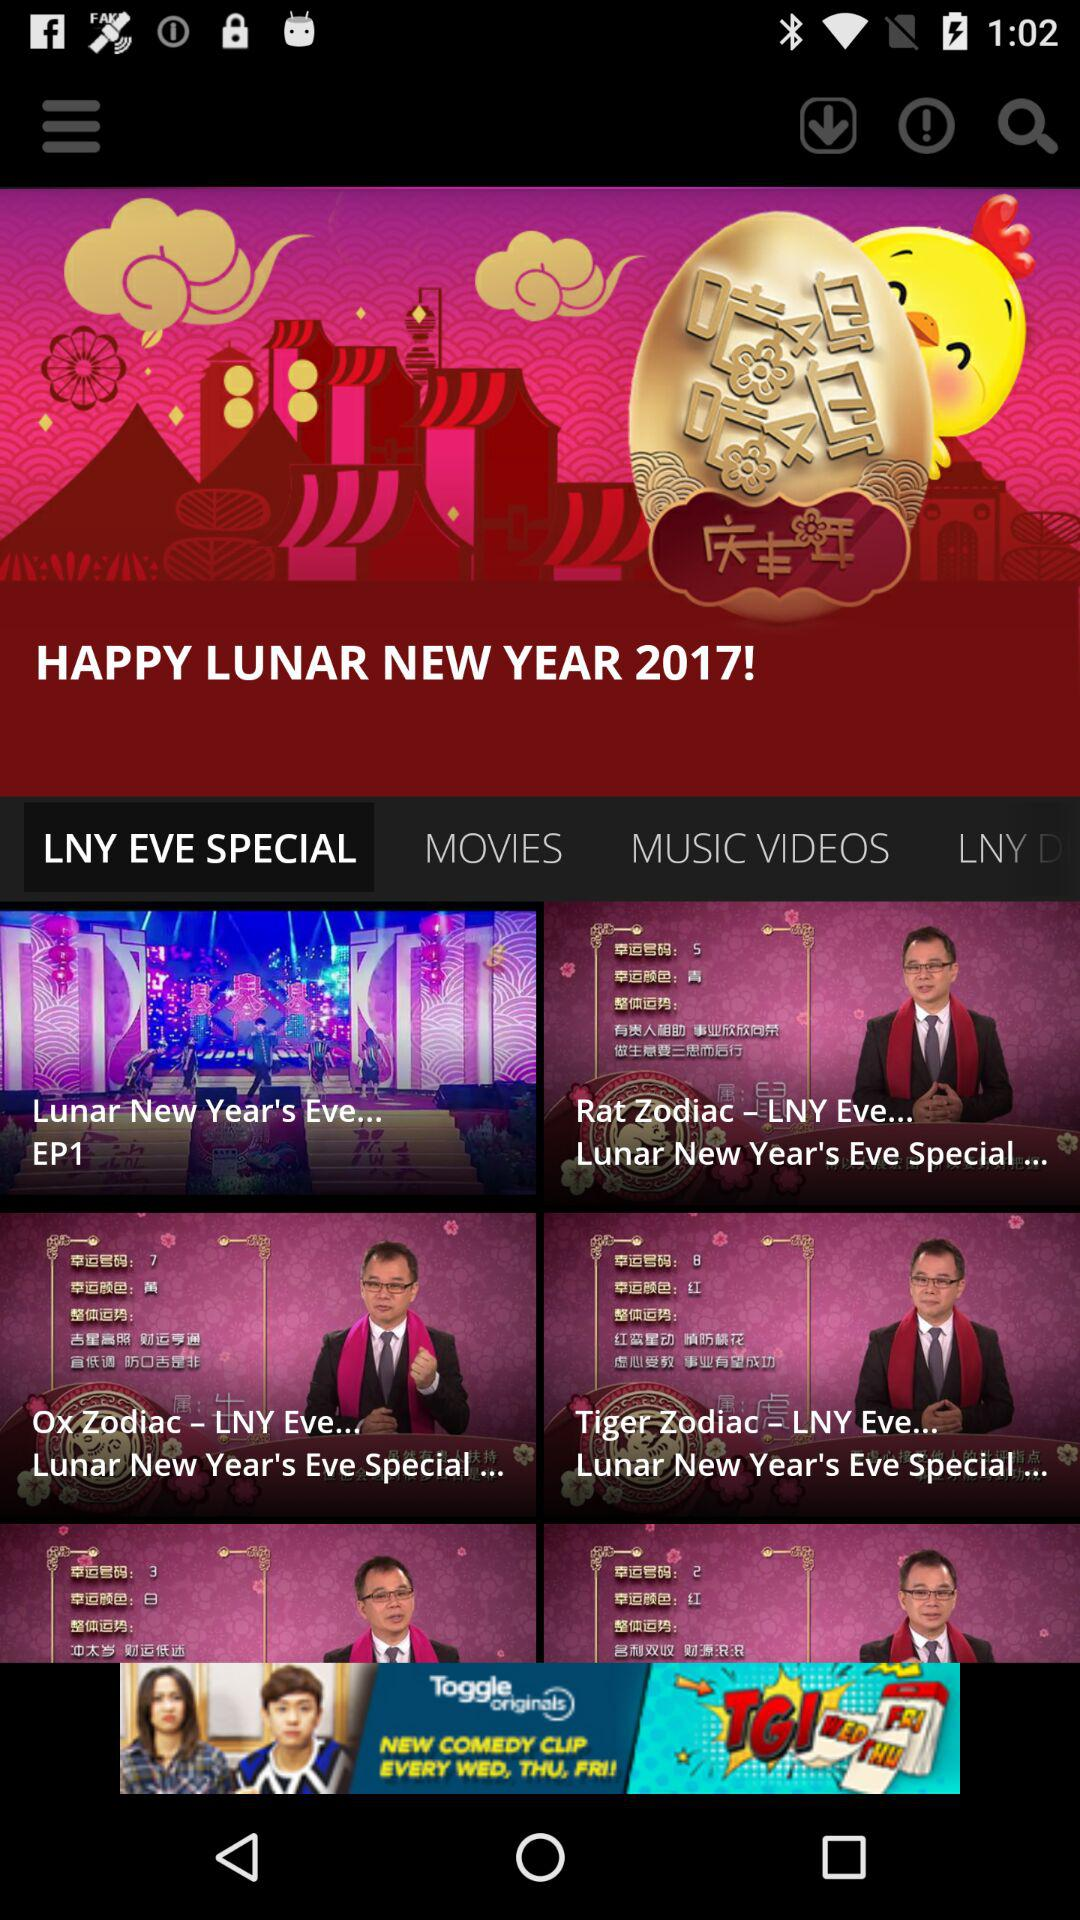Which tab of the application are we on? You are on the "LNY EVE SPECIAL" tab of the application. 